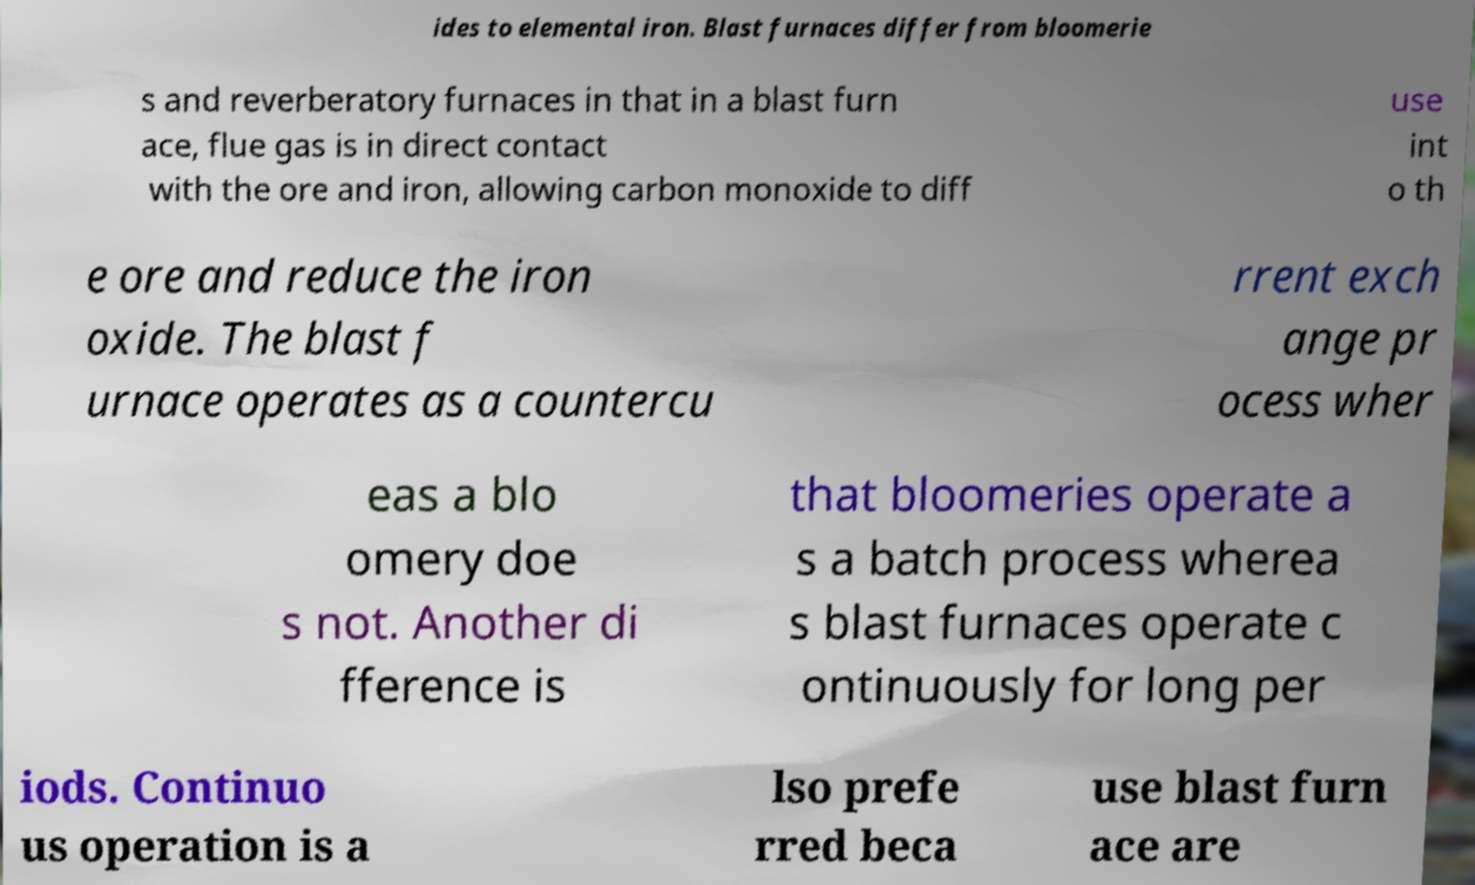For documentation purposes, I need the text within this image transcribed. Could you provide that? ides to elemental iron. Blast furnaces differ from bloomerie s and reverberatory furnaces in that in a blast furn ace, flue gas is in direct contact with the ore and iron, allowing carbon monoxide to diff use int o th e ore and reduce the iron oxide. The blast f urnace operates as a countercu rrent exch ange pr ocess wher eas a blo omery doe s not. Another di fference is that bloomeries operate a s a batch process wherea s blast furnaces operate c ontinuously for long per iods. Continuo us operation is a lso prefe rred beca use blast furn ace are 